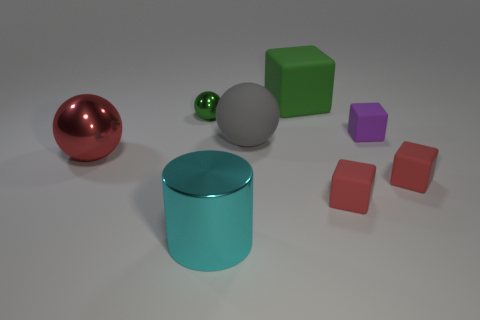Subtract 1 blocks. How many blocks are left? 3 Add 2 tiny objects. How many objects exist? 10 Subtract all cylinders. How many objects are left? 7 Add 5 small red rubber things. How many small red rubber things exist? 7 Subtract 1 cyan cylinders. How many objects are left? 7 Subtract all big blue matte blocks. Subtract all tiny objects. How many objects are left? 4 Add 2 small red things. How many small red things are left? 4 